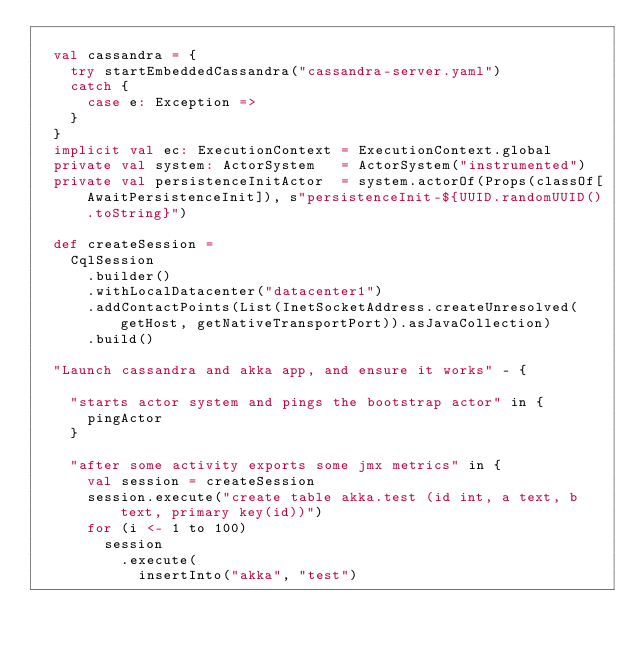<code> <loc_0><loc_0><loc_500><loc_500><_Scala_>
  val cassandra = {
    try startEmbeddedCassandra("cassandra-server.yaml")
    catch {
      case e: Exception =>
    }
  }
  implicit val ec: ExecutionContext = ExecutionContext.global
  private val system: ActorSystem   = ActorSystem("instrumented")
  private val persistenceInitActor  = system.actorOf(Props(classOf[AwaitPersistenceInit]), s"persistenceInit-${UUID.randomUUID().toString}")

  def createSession =
    CqlSession
      .builder()
      .withLocalDatacenter("datacenter1")
      .addContactPoints(List(InetSocketAddress.createUnresolved(getHost, getNativeTransportPort)).asJavaCollection)
      .build()

  "Launch cassandra and akka app, and ensure it works" - {

    "starts actor system and pings the bootstrap actor" in {
      pingActor
    }

    "after some activity exports some jmx metrics" in {
      val session = createSession
      session.execute("create table akka.test (id int, a text, b text, primary key(id))")
      for (i <- 1 to 100)
        session
          .execute(
            insertInto("akka", "test")</code> 